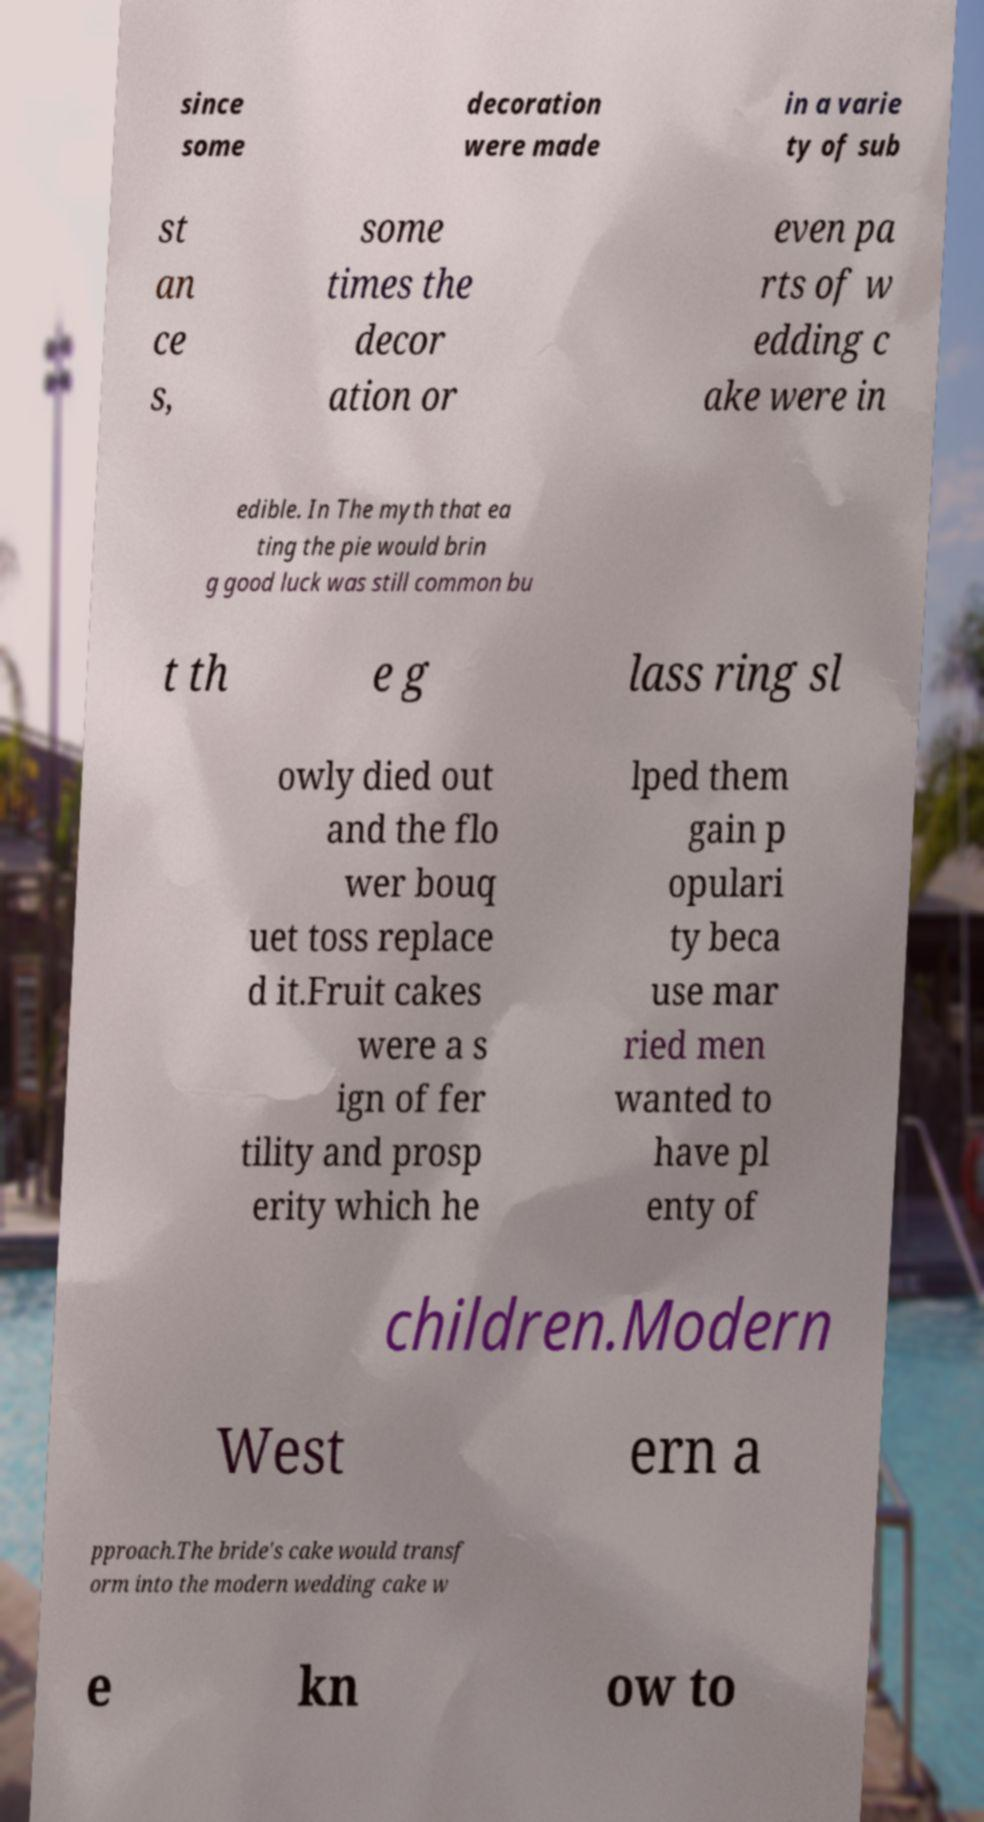For documentation purposes, I need the text within this image transcribed. Could you provide that? since some decoration were made in a varie ty of sub st an ce s, some times the decor ation or even pa rts of w edding c ake were in edible. In The myth that ea ting the pie would brin g good luck was still common bu t th e g lass ring sl owly died out and the flo wer bouq uet toss replace d it.Fruit cakes were a s ign of fer tility and prosp erity which he lped them gain p opulari ty beca use mar ried men wanted to have pl enty of children.Modern West ern a pproach.The bride's cake would transf orm into the modern wedding cake w e kn ow to 